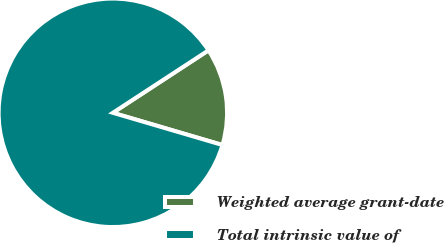Convert chart to OTSL. <chart><loc_0><loc_0><loc_500><loc_500><pie_chart><fcel>Weighted average grant-date<fcel>Total intrinsic value of<nl><fcel>13.76%<fcel>86.24%<nl></chart> 